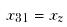<formula> <loc_0><loc_0><loc_500><loc_500>x _ { 3 1 } = x _ { z }</formula> 